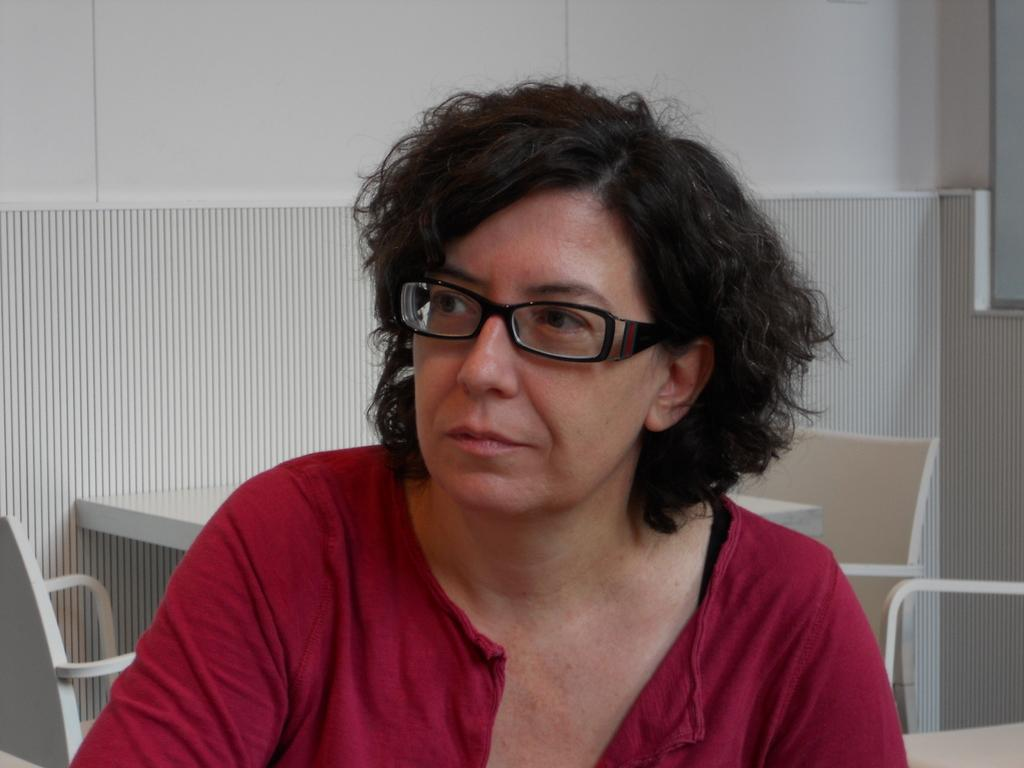Who is present in the image? There is a woman in the image. What is the woman wearing on her face? The woman is wearing spectacles. What can be seen in the background of the image? There is a table, chairs, and a wall in the background of the image. What type of island can be seen in the background of the image? There is no island present in the image; it features a woman wearing spectacles and a background with a table, chairs, and a wall. 